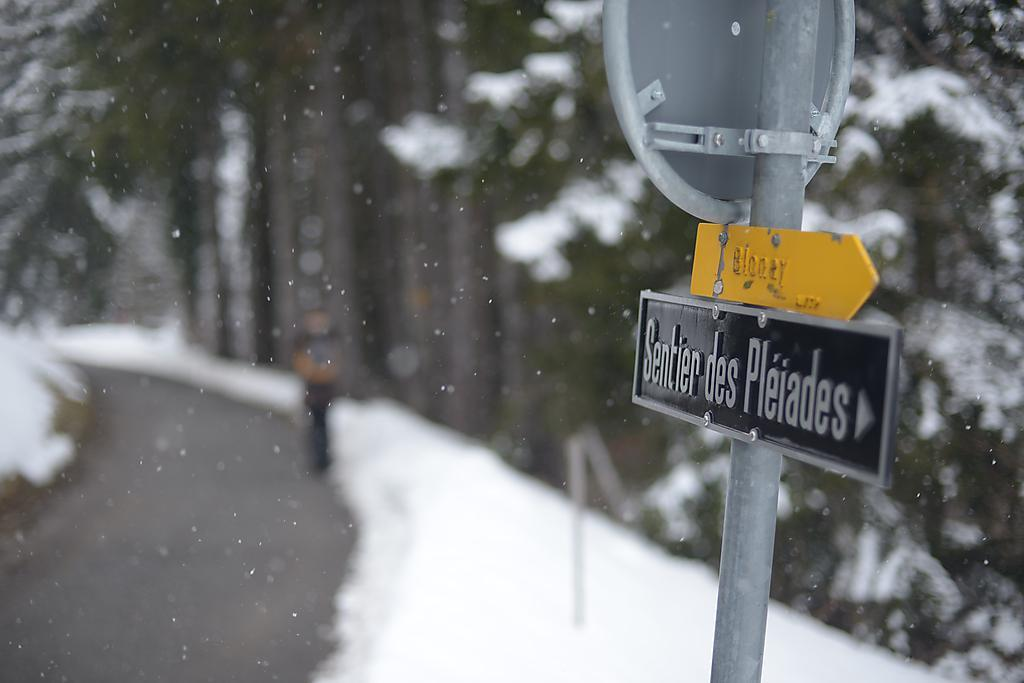What is located on the right side of the image? There is a sign board on the right side of the image. What is on the left side of the image? There is a road on the left side of the image. What is the weather like in the image? Snow is present in the image, indicating a cold or wintry weather. What can be seen in the background of the image? There are trees in the background of the image. What type of stew is being served on the road in the image? There is no stew present in the image. 